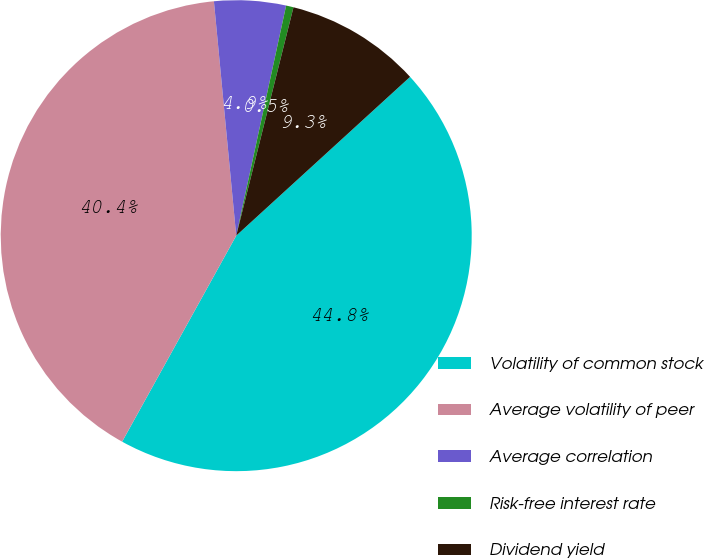Convert chart to OTSL. <chart><loc_0><loc_0><loc_500><loc_500><pie_chart><fcel>Volatility of common stock<fcel>Average volatility of peer<fcel>Average correlation<fcel>Risk-free interest rate<fcel>Dividend yield<nl><fcel>44.83%<fcel>40.44%<fcel>4.91%<fcel>0.51%<fcel>9.31%<nl></chart> 